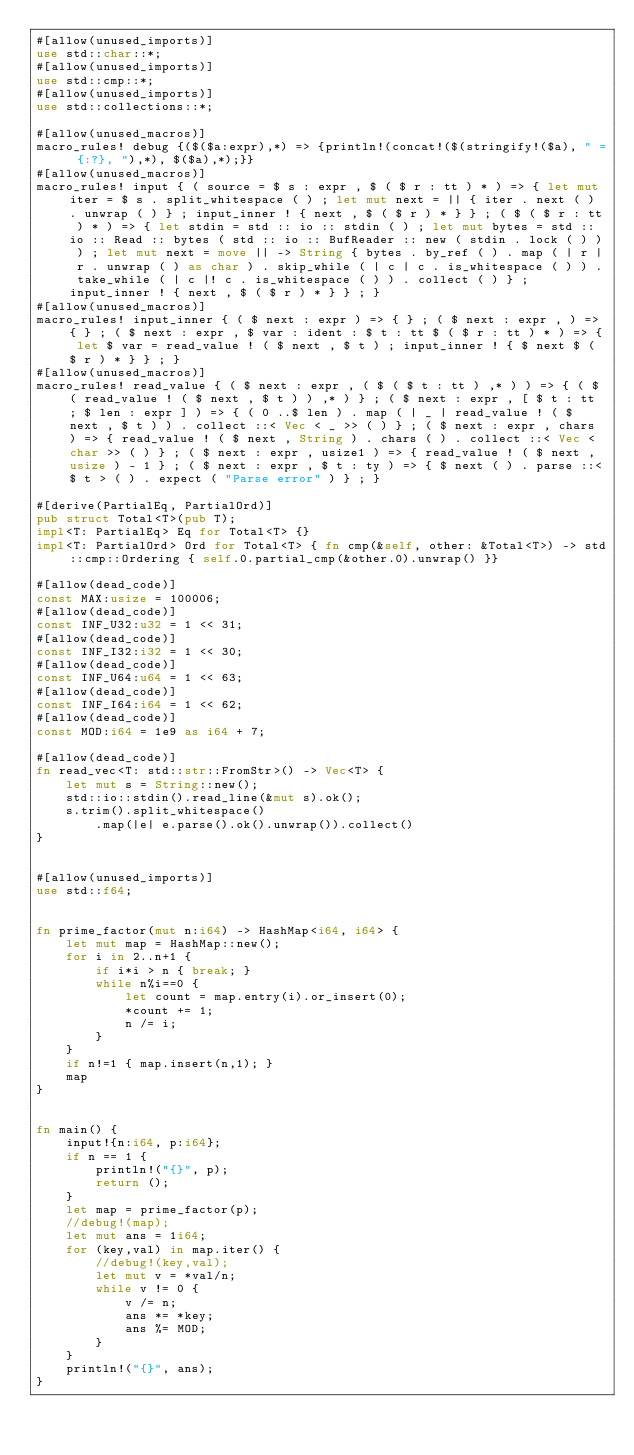Convert code to text. <code><loc_0><loc_0><loc_500><loc_500><_Rust_>#[allow(unused_imports)]
use std::char::*;
#[allow(unused_imports)]
use std::cmp::*;
#[allow(unused_imports)]
use std::collections::*;

#[allow(unused_macros)]
macro_rules! debug {($($a:expr),*) => {println!(concat!($(stringify!($a), " = {:?}, "),*), $($a),*);}}
#[allow(unused_macros)]
macro_rules! input { ( source = $ s : expr , $ ( $ r : tt ) * ) => { let mut iter = $ s . split_whitespace ( ) ; let mut next = || { iter . next ( ) . unwrap ( ) } ; input_inner ! { next , $ ( $ r ) * } } ; ( $ ( $ r : tt ) * ) => { let stdin = std :: io :: stdin ( ) ; let mut bytes = std :: io :: Read :: bytes ( std :: io :: BufReader :: new ( stdin . lock ( ) ) ) ; let mut next = move || -> String { bytes . by_ref ( ) . map ( | r | r . unwrap ( ) as char ) . skip_while ( | c | c . is_whitespace ( ) ) . take_while ( | c |! c . is_whitespace ( ) ) . collect ( ) } ; input_inner ! { next , $ ( $ r ) * } } ; }
#[allow(unused_macros)]
macro_rules! input_inner { ( $ next : expr ) => { } ; ( $ next : expr , ) => { } ; ( $ next : expr , $ var : ident : $ t : tt $ ( $ r : tt ) * ) => { let $ var = read_value ! ( $ next , $ t ) ; input_inner ! { $ next $ ( $ r ) * } } ; }
#[allow(unused_macros)]
macro_rules! read_value { ( $ next : expr , ( $ ( $ t : tt ) ,* ) ) => { ( $ ( read_value ! ( $ next , $ t ) ) ,* ) } ; ( $ next : expr , [ $ t : tt ; $ len : expr ] ) => { ( 0 ..$ len ) . map ( | _ | read_value ! ( $ next , $ t ) ) . collect ::< Vec < _ >> ( ) } ; ( $ next : expr , chars ) => { read_value ! ( $ next , String ) . chars ( ) . collect ::< Vec < char >> ( ) } ; ( $ next : expr , usize1 ) => { read_value ! ( $ next , usize ) - 1 } ; ( $ next : expr , $ t : ty ) => { $ next ( ) . parse ::<$ t > ( ) . expect ( "Parse error" ) } ; }

#[derive(PartialEq, PartialOrd)]
pub struct Total<T>(pub T);
impl<T: PartialEq> Eq for Total<T> {}
impl<T: PartialOrd> Ord for Total<T> { fn cmp(&self, other: &Total<T>) -> std::cmp::Ordering { self.0.partial_cmp(&other.0).unwrap() }}

#[allow(dead_code)]
const MAX:usize = 100006;
#[allow(dead_code)]
const INF_U32:u32 = 1 << 31;
#[allow(dead_code)]
const INF_I32:i32 = 1 << 30;
#[allow(dead_code)]
const INF_U64:u64 = 1 << 63;
#[allow(dead_code)]
const INF_I64:i64 = 1 << 62;
#[allow(dead_code)]
const MOD:i64 = 1e9 as i64 + 7;

#[allow(dead_code)]
fn read_vec<T: std::str::FromStr>() -> Vec<T> {
    let mut s = String::new();
    std::io::stdin().read_line(&mut s).ok();
    s.trim().split_whitespace()
        .map(|e| e.parse().ok().unwrap()).collect()
}


#[allow(unused_imports)]
use std::f64;


fn prime_factor(mut n:i64) -> HashMap<i64, i64> {
    let mut map = HashMap::new();
    for i in 2..n+1 {
        if i*i > n { break; }
        while n%i==0 {
            let count = map.entry(i).or_insert(0);
            *count += 1;
            n /= i;
        }
    }
    if n!=1 { map.insert(n,1); }
    map
}


fn main() {
    input!{n:i64, p:i64};
    if n == 1 {
        println!("{}", p);
        return ();
    }
    let map = prime_factor(p);
    //debug!(map);
    let mut ans = 1i64;
    for (key,val) in map.iter() {
        //debug!(key,val);
        let mut v = *val/n;
        while v != 0 {
            v /= n;
            ans *= *key;
            ans %= MOD;
        }
    }
    println!("{}", ans);
}</code> 